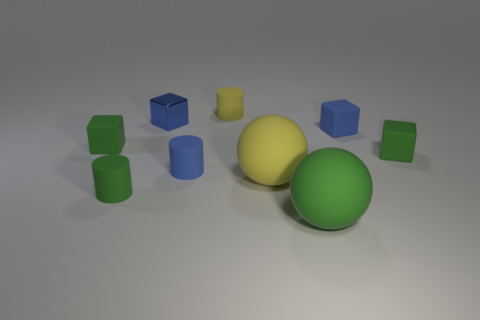There is a matte cylinder behind the metal object; does it have the same color as the tiny metallic thing?
Your answer should be very brief. No. Are there more rubber objects that are to the left of the small yellow matte cylinder than big yellow balls that are to the left of the small blue shiny object?
Make the answer very short. Yes. Is there anything else that has the same color as the shiny thing?
Keep it short and to the point. Yes. What number of things are tiny green objects or tiny yellow rubber balls?
Keep it short and to the point. 3. Is the size of the green rubber cylinder that is left of the blue rubber block the same as the small blue metal cube?
Your answer should be compact. Yes. What number of other objects are the same size as the green rubber cylinder?
Offer a terse response. 6. Is there a tiny green matte cube?
Offer a very short reply. Yes. How big is the rubber cylinder behind the blue block left of the large green rubber ball?
Give a very brief answer. Small. Do the small shiny thing behind the yellow ball and the rubber cylinder in front of the yellow rubber ball have the same color?
Ensure brevity in your answer.  No. There is a small matte object that is both on the left side of the tiny yellow matte cylinder and on the right side of the metal cube; what is its color?
Your response must be concise. Blue. 